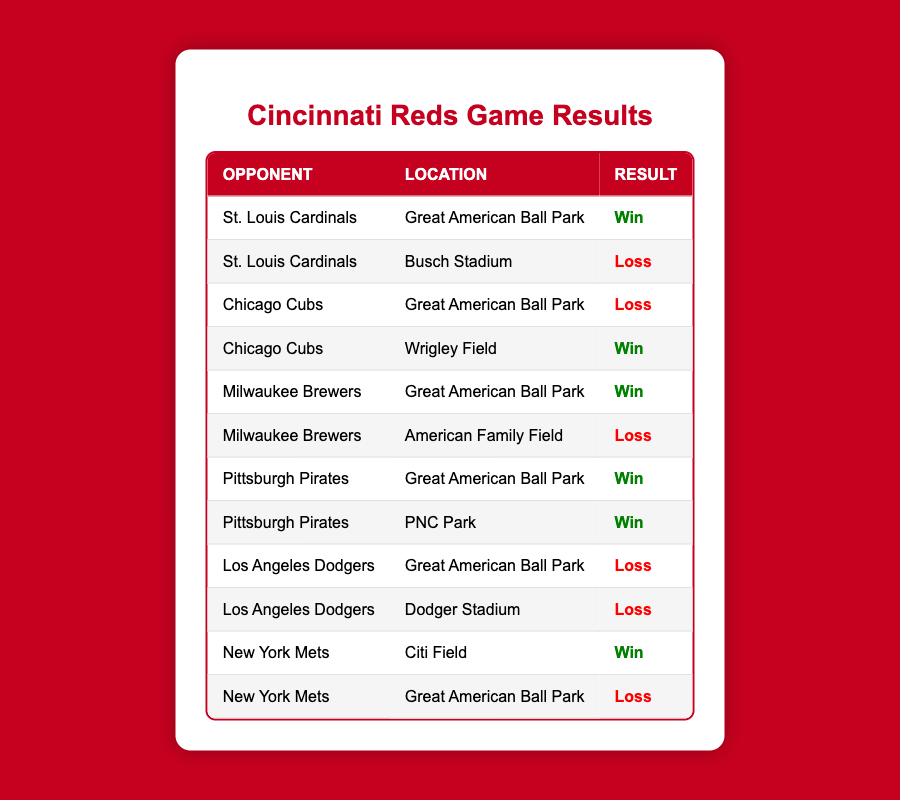What is the result of the game against the St. Louis Cardinals at Great American Ball Park? The table shows that in the game against the St. Louis Cardinals at Great American Ball Park, the result is a "Win".
Answer: Win How many games did the Cincinnati Reds win when playing at Great American Ball Park? By looking at the results of the games listed, the Reds won against the St. Louis Cardinals, Milwaukee Brewers, and Pittsburgh Pirates at Great American Ball Park, which totals to 3 wins.
Answer: 3 Did the Cincinnati Reds lose any games against the Los Angeles Dodgers at home? According to the table, the Reds lost both games against the Los Angeles Dodgers at Great American Ball Park.
Answer: Yes What is the total number of losses against the Milwaukee Brewers? The Reds lost 1 game against the Milwaukee Brewers at American Family Field, as there are no losses noted at Great American Ball Park against them. Therefore, the total losses against the Brewers are 1.
Answer: 1 Which opponent had the most games played against the Cincinnati Reds in these results? The table shows only the St. Louis Cardinals, Chicago Cubs, Milwaukee Brewers, Pittsburgh Pirates, Los Angeles Dodgers, and New York Mets as opponents. The St. Louis Cardinals and New York Mets had 2 games each while others had 2 games each, making it a tie for opponents but they all played two games against the Reds.
Answer: All opponents played 2 games What was the Reds' overall winning percentage when playing at Great American Ball Park? At Great American Ball Park, the Reds had 4 games listed (against St. Louis Cardinals, Chicago Cubs, Milwaukee Brewers, and Pittsburgh Pirates). Out of these 3 games were wins. The winning percentage is calculated as (3 wins / 6 total games) = 0.5, which is 50%.
Answer: 50% How many total games did the Cincinnati Reds play against the Chicago Cubs, and what were the results? The Reds played 2 games against the Chicago Cubs. They won 1 game on the road at Wrigley Field and lost 1 game at Great American Ball Park.
Answer: 2 games (1 win, 1 loss) Was there any game where the Reds won at home against the New York Mets? The table indicates that the Reds lost to the New York Mets while playing at Great American Ball Park, confirming that there was no home win against them.
Answer: No 